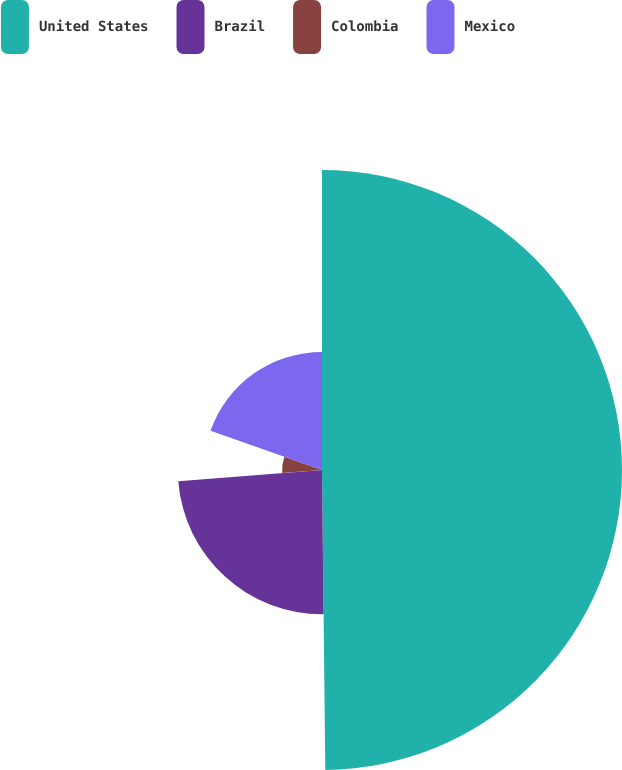Convert chart. <chart><loc_0><loc_0><loc_500><loc_500><pie_chart><fcel>United States<fcel>Brazil<fcel>Colombia<fcel>Mexico<nl><fcel>49.83%<fcel>23.94%<fcel>6.62%<fcel>19.62%<nl></chart> 